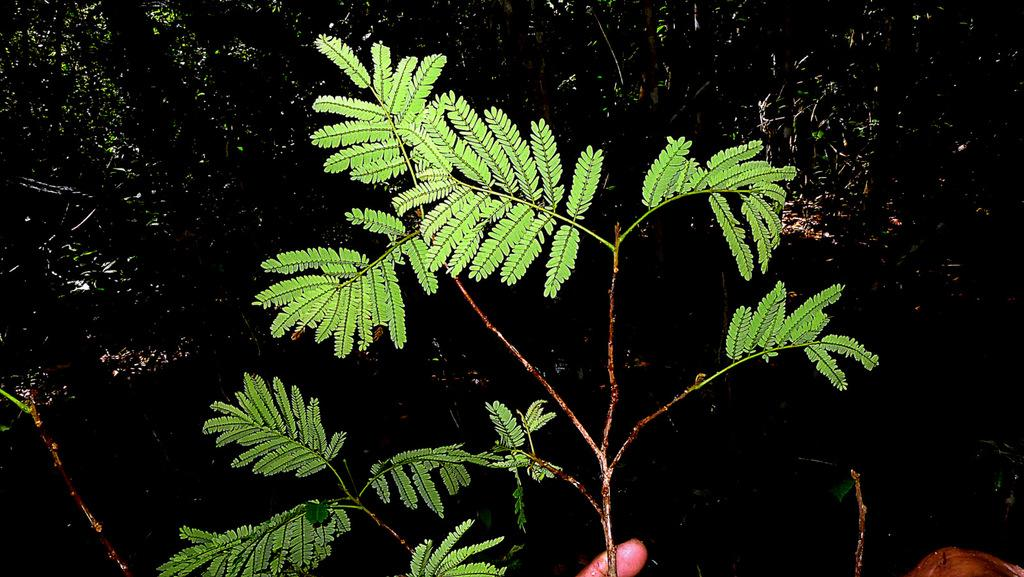What type of living organism can be seen in the image? There is a plant in the image. Can you identify any body parts of a person in the image? Yes, a person's finger is visible in the image. What else can be seen in the image besides the plant and the finger? There are other objects in the image. How would you describe the overall lighting in the image? The background of the image is dark. Reasoning: Let'g: Let's think step by step in order to produce the conversation. We start by identifying the main subject in the image, which is the plant. Then, we expand the conversation to include other details about the image, such as the presence of a person's finger, other objects, and the dark background. Each question is designed to elicit a specific detail about the image that is known from the provided facts. Absurd Question/Answer: What type of slave is depicted in the image? There is no depiction of a slave in the image; it only features a plant and a person's finger. How many worms can be seen crawling on the plant in the image? There are no worms present in the image; it only features a plant and a person's finger. How many worms can be seen crawling on the plant in the image? There are no worms present in the image; it only features a plant and a person's finger. What type of mom is depicted in the image? There is no depiction of a mom in the image; it only features a plant and a person's finger. 